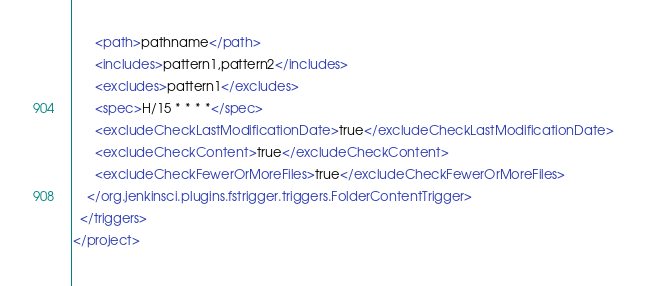<code> <loc_0><loc_0><loc_500><loc_500><_XML_>      <path>pathname</path>
      <includes>pattern1,pattern2</includes>
      <excludes>pattern1</excludes>
      <spec>H/15 * * * *</spec>
      <excludeCheckLastModificationDate>true</excludeCheckLastModificationDate>
      <excludeCheckContent>true</excludeCheckContent>
      <excludeCheckFewerOrMoreFiles>true</excludeCheckFewerOrMoreFiles>
    </org.jenkinsci.plugins.fstrigger.triggers.FolderContentTrigger>
  </triggers>
</project></code> 